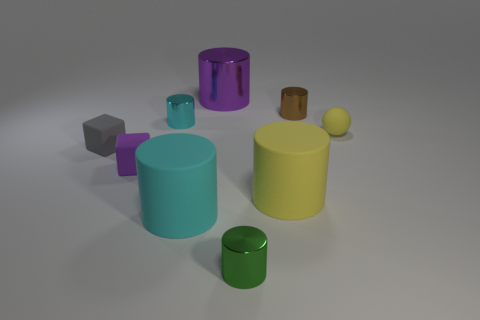Are there any other things that have the same shape as the small yellow object?
Provide a short and direct response. No. Are the small cylinder that is to the left of the tiny green metallic cylinder and the purple object that is right of the purple block made of the same material?
Give a very brief answer. Yes. There is a purple thing left of the metallic object to the left of the large thing that is on the left side of the purple cylinder; how big is it?
Give a very brief answer. Small. How many large cyan things are the same material as the purple cube?
Your response must be concise. 1. Is the number of tiny brown cylinders less than the number of rubber objects?
Your answer should be very brief. Yes. What is the size of the purple metallic object that is the same shape as the small green thing?
Your answer should be compact. Large. Do the small thing that is left of the tiny purple rubber cube and the yellow ball have the same material?
Your answer should be compact. Yes. Is the shape of the small gray object the same as the big cyan rubber object?
Provide a succinct answer. No. How many things are either rubber objects that are behind the cyan matte object or large cyan cylinders?
Your answer should be compact. 5. What is the size of the other cylinder that is made of the same material as the big cyan cylinder?
Your answer should be very brief. Large. 